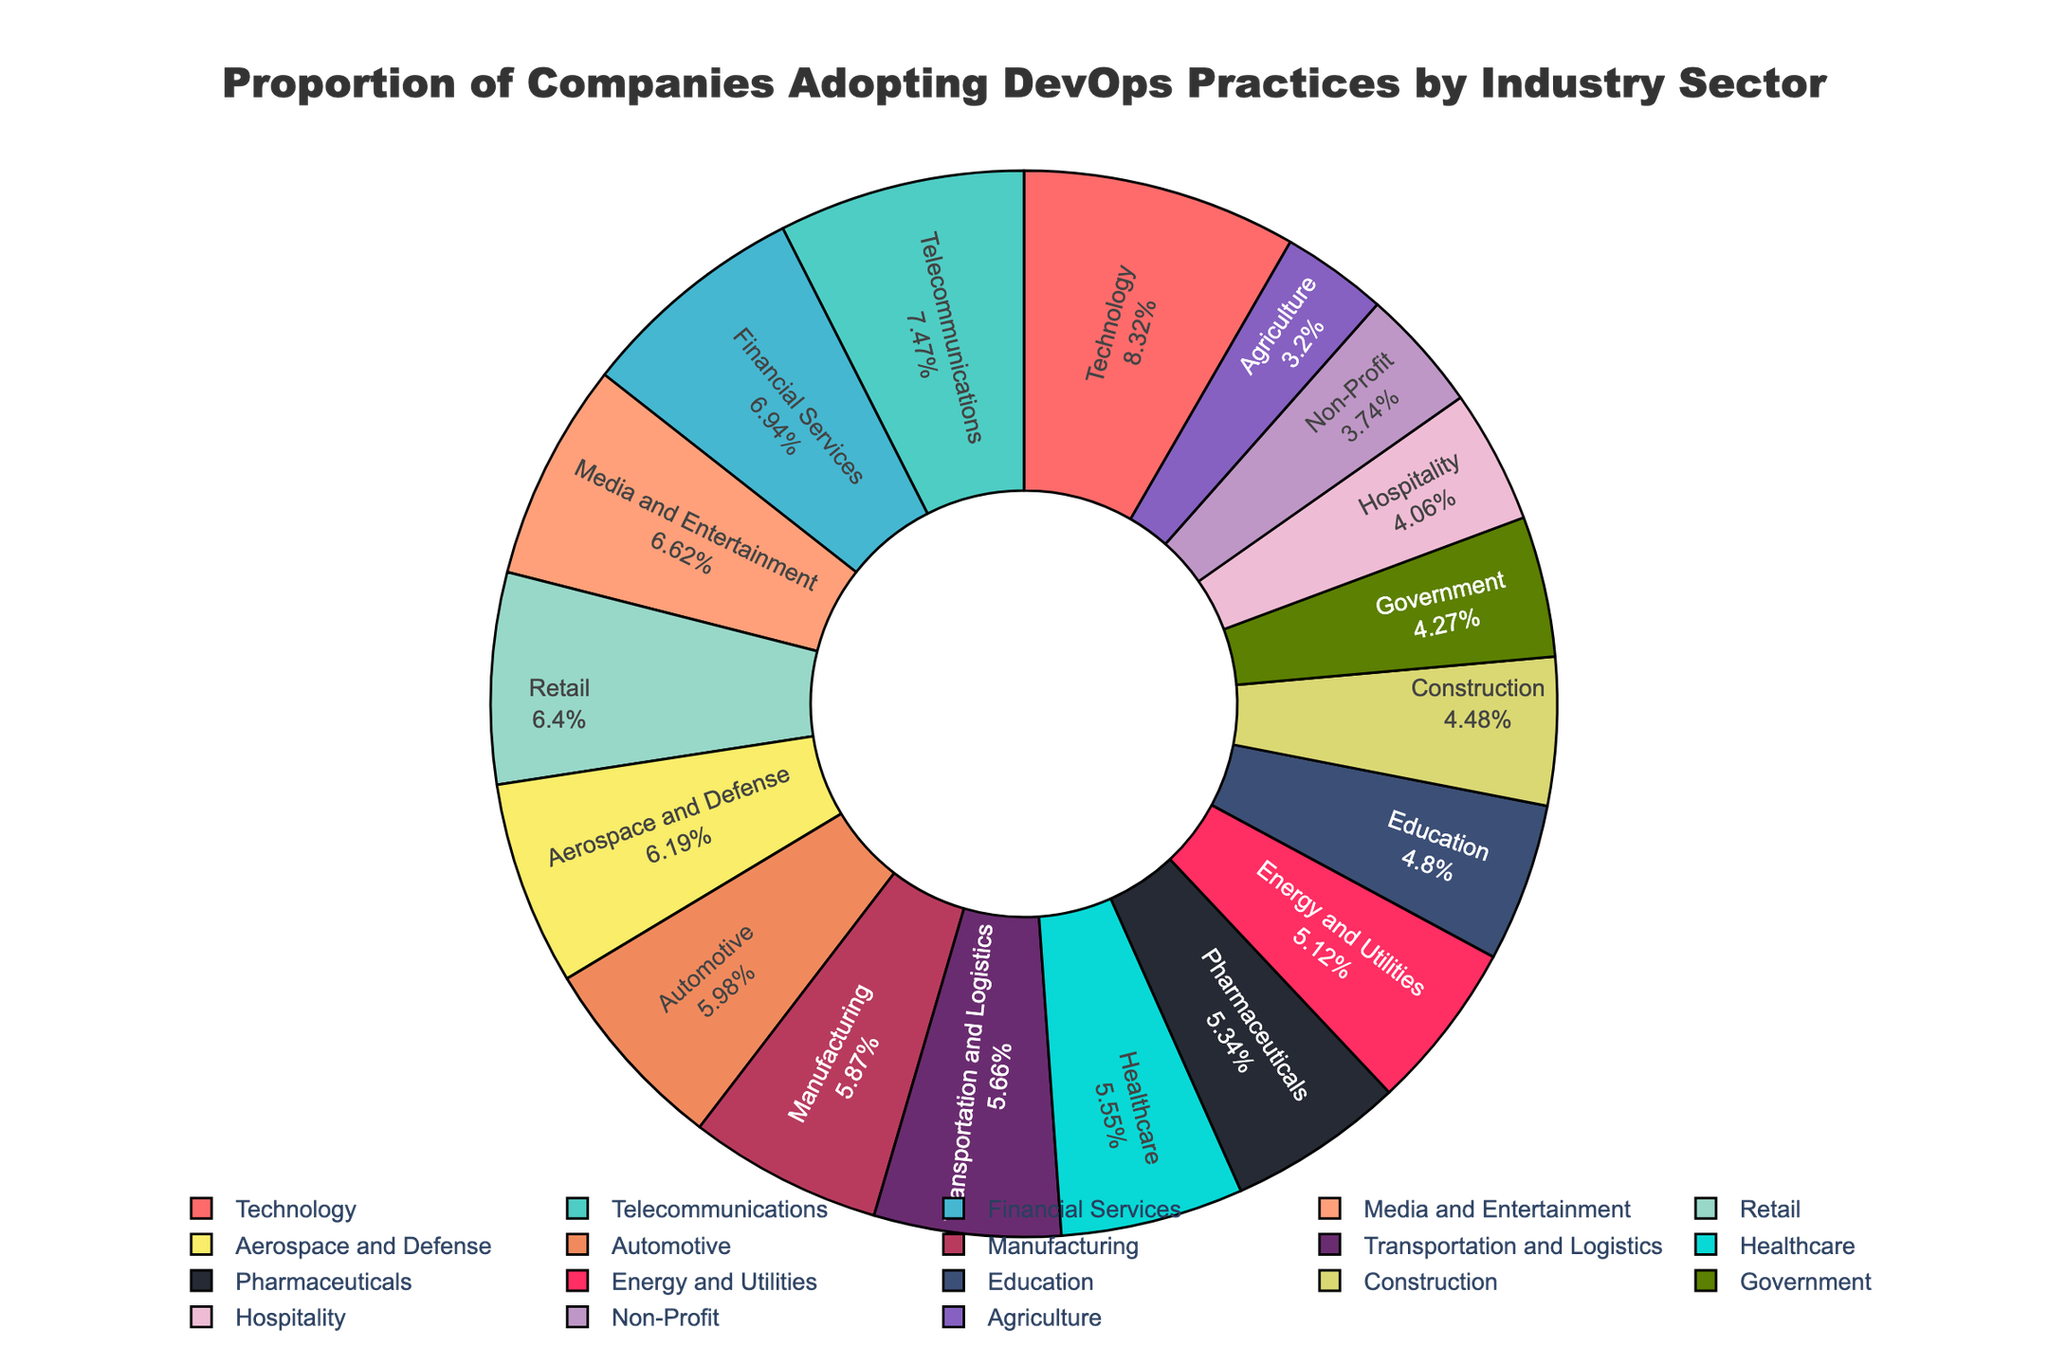What industry sector has the highest adoption of DevOps practices? The Technology sector shows the highest percentage of adoption. This can be inferred from the pie chart where the Technology sector occupies the largest segment.
Answer: Technology Compare the adoption rates of the Technology sector and the Government sector. Which one is higher and by how much? The Technology sector has a 78% adoption rate, while the Government sector has a 40% adoption rate. The difference between them is 78% - 40% = 38%.
Answer: Technology is higher by 38% List the top three industry sectors in terms of DevOps adoption. By looking at the segments with the largest percentages, the top three sectors are Technology (78%), Telecommunications (70%), and Financial Services (65%).
Answer: Technology, Telecommunications, Financial Services What is the combined percentage of DevOps adoption for Healthcare and Retail sectors? Healthcare has 52% and Retail has 60%. Adding these percentages gives 52% + 60% = 112%.
Answer: 112% Which industry has a DevOps adoption rate closest to 50%? The pie chart shows that Pharmaceuticals has a DevOps adoption rate of 50%, which is exactly 50%.
Answer: Pharmaceuticals Which sector has a lower DevOps adoption rate, Education or Construction? By comparing the segments, Education has a 45% adoption rate while Construction has a 42% adoption rate. Construction is lower.
Answer: Construction What is the average adoption rate across the Retail, Manufacturing, and Automotive sectors? The adoption rates are Retail (60%), Manufacturing (55%), and Automotive (56%). The average is (60 + 55 + 56) / 3 = 57%.
Answer: 57% Compare the adoption rates of the Energy and Utilities sector to the Aerospace and Defense sector. Which one is higher and by how much? Energy and Utilities has a 48% adoption rate, while Aerospace and Defense has a 58% adoption rate. The difference between them is 58% - 48% = 10%.
Answer: Aerospace and Defense is higher by 10% Identify the sector with the lowest adoption rate of DevOps practices. The smallest segment in the pie chart corresponds to Agriculture, which has a 30% adoption rate.
Answer: Agriculture 